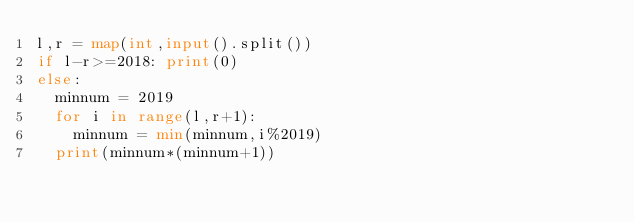Convert code to text. <code><loc_0><loc_0><loc_500><loc_500><_Python_>l,r = map(int,input().split())
if l-r>=2018: print(0)
else:
  minnum = 2019
  for i in range(l,r+1):
    minnum = min(minnum,i%2019)
  print(minnum*(minnum+1))
    
</code> 